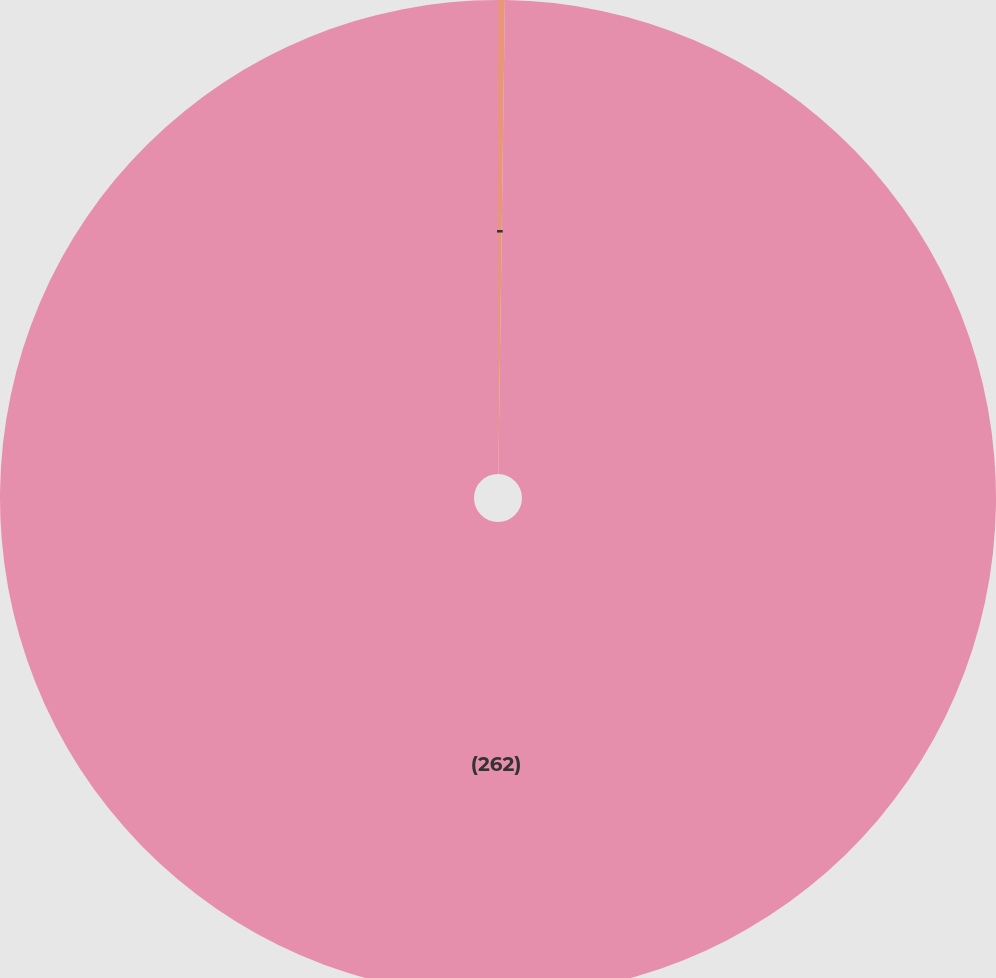Convert chart to OTSL. <chart><loc_0><loc_0><loc_500><loc_500><pie_chart><fcel>-<fcel>(262)<nl><fcel>0.22%<fcel>99.78%<nl></chart> 